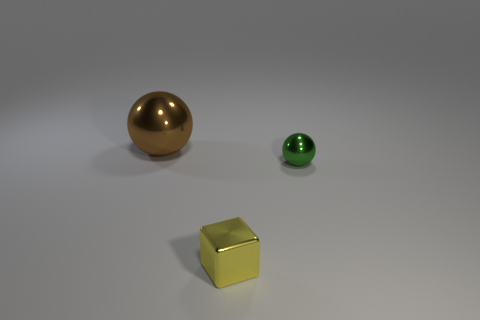Subtract all spheres. How many objects are left? 1 Add 1 large brown metal cylinders. How many objects exist? 4 Add 1 tiny green things. How many tiny green things are left? 2 Add 2 tiny green metal balls. How many tiny green metal balls exist? 3 Subtract 0 cyan balls. How many objects are left? 3 Subtract all small green objects. Subtract all tiny yellow metal blocks. How many objects are left? 1 